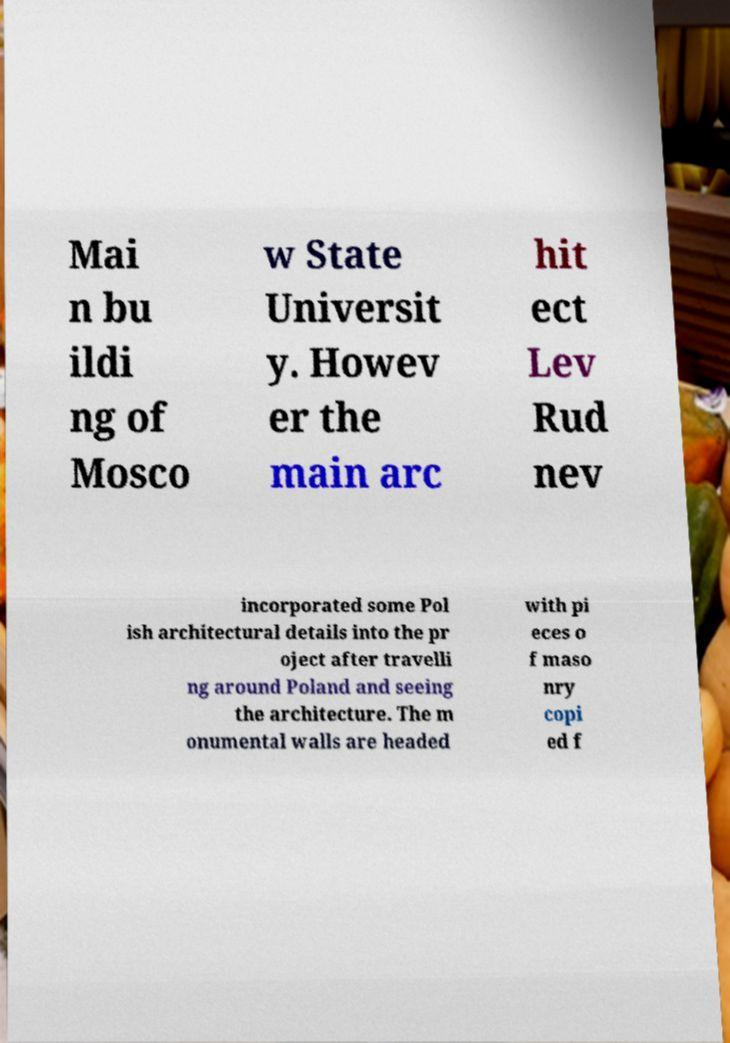There's text embedded in this image that I need extracted. Can you transcribe it verbatim? Mai n bu ildi ng of Mosco w State Universit y. Howev er the main arc hit ect Lev Rud nev incorporated some Pol ish architectural details into the pr oject after travelli ng around Poland and seeing the architecture. The m onumental walls are headed with pi eces o f maso nry copi ed f 